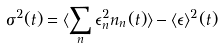Convert formula to latex. <formula><loc_0><loc_0><loc_500><loc_500>\sigma ^ { 2 } ( t ) = \langle \sum _ { n } \epsilon _ { n } ^ { 2 } n _ { n } ( t ) \rangle - \langle \epsilon \rangle ^ { 2 } ( t )</formula> 